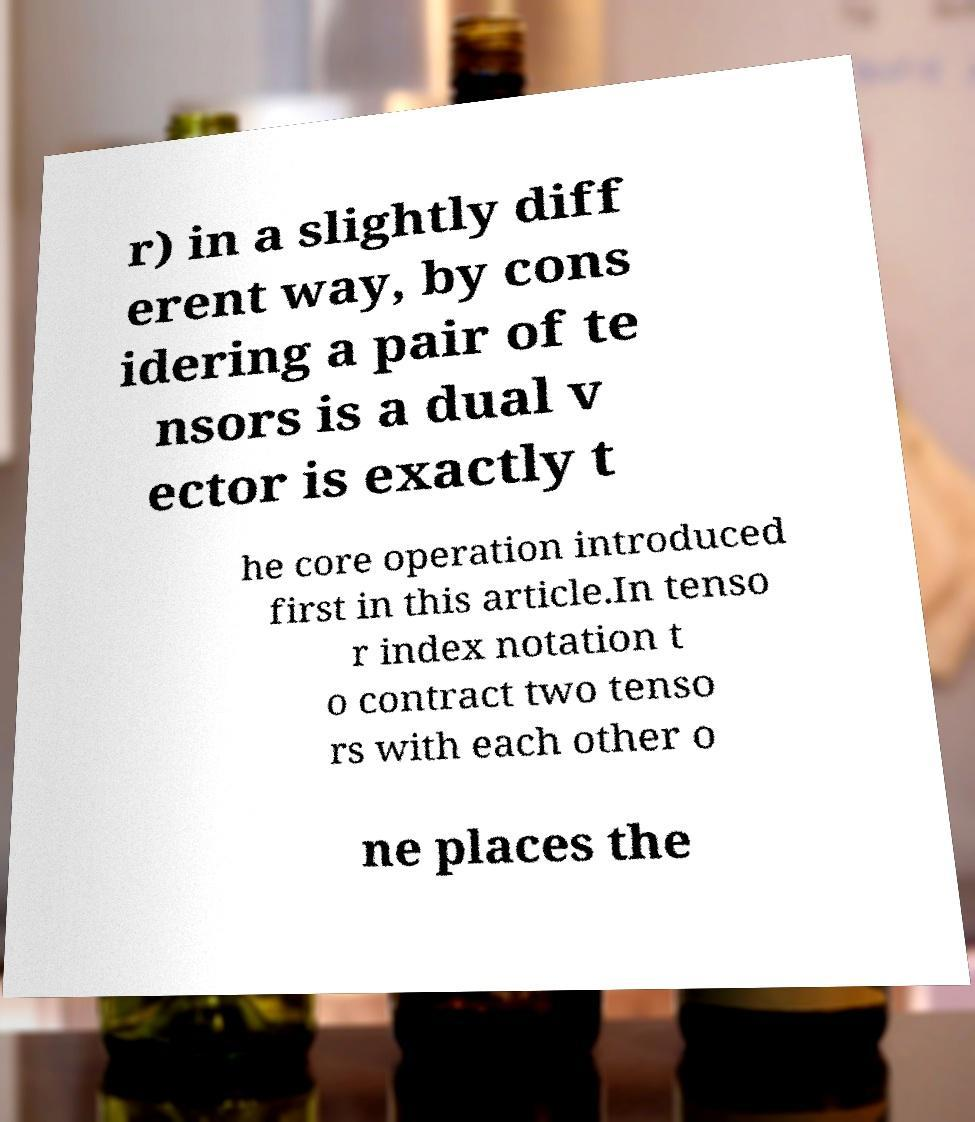I need the written content from this picture converted into text. Can you do that? r) in a slightly diff erent way, by cons idering a pair of te nsors is a dual v ector is exactly t he core operation introduced first in this article.In tenso r index notation t o contract two tenso rs with each other o ne places the 